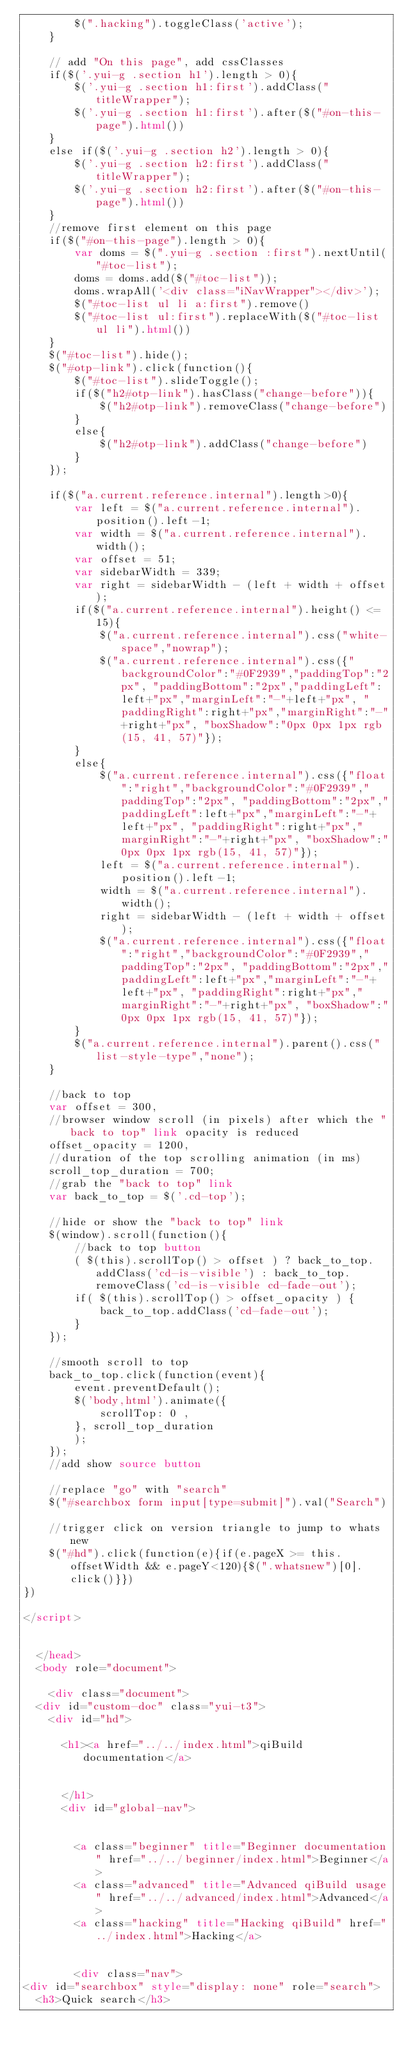Convert code to text. <code><loc_0><loc_0><loc_500><loc_500><_HTML_>        $(".hacking").toggleClass('active');
    }

    // add "On this page", add cssClasses
    if($('.yui-g .section h1').length > 0){
        $('.yui-g .section h1:first').addClass("titleWrapper");
        $('.yui-g .section h1:first').after($("#on-this-page").html())
    }
    else if($('.yui-g .section h2').length > 0){
        $('.yui-g .section h2:first').addClass("titleWrapper");
        $('.yui-g .section h2:first').after($("#on-this-page").html())
    }
    //remove first element on this page
    if($("#on-this-page").length > 0){
        var doms = $(".yui-g .section :first").nextUntil("#toc-list");
        doms = doms.add($("#toc-list"));
        doms.wrapAll('<div class="iNavWrapper"></div>');
        $("#toc-list ul li a:first").remove()
        $("#toc-list ul:first").replaceWith($("#toc-list ul li").html())
    }
    $("#toc-list").hide();
    $("#otp-link").click(function(){
        $("#toc-list").slideToggle();
        if($("h2#otp-link").hasClass("change-before")){
            $("h2#otp-link").removeClass("change-before")
        }
        else{
            $("h2#otp-link").addClass("change-before")
        }
    });

    if($("a.current.reference.internal").length>0){
        var left = $("a.current.reference.internal").position().left-1;
        var width = $("a.current.reference.internal").width();
        var offset = 51;
        var sidebarWidth = 339;
        var right = sidebarWidth - (left + width + offset);
        if($("a.current.reference.internal").height() <= 15){
            $("a.current.reference.internal").css("white-space","nowrap");
            $("a.current.reference.internal").css({"backgroundColor":"#0F2939","paddingTop":"2px", "paddingBottom":"2px","paddingLeft":left+"px","marginLeft":"-"+left+"px", "paddingRight":right+"px","marginRight":"-"+right+"px", "boxShadow":"0px 0px 1px rgb(15, 41, 57)"});
        }
        else{
            $("a.current.reference.internal").css({"float":"right","backgroundColor":"#0F2939","paddingTop":"2px", "paddingBottom":"2px","paddingLeft":left+"px","marginLeft":"-"+left+"px", "paddingRight":right+"px","marginRight":"-"+right+"px", "boxShadow":"0px 0px 1px rgb(15, 41, 57)"});
            left = $("a.current.reference.internal").position().left-1;
            width = $("a.current.reference.internal").width();
            right = sidebarWidth - (left + width + offset);
            $("a.current.reference.internal").css({"float":"right","backgroundColor":"#0F2939","paddingTop":"2px", "paddingBottom":"2px","paddingLeft":left+"px","marginLeft":"-"+left+"px", "paddingRight":right+"px","marginRight":"-"+right+"px", "boxShadow":"0px 0px 1px rgb(15, 41, 57)"});
        }
        $("a.current.reference.internal").parent().css("list-style-type","none");
    }

    //back to top
    var offset = 300,
    //browser window scroll (in pixels) after which the "back to top" link opacity is reduced
    offset_opacity = 1200,
    //duration of the top scrolling animation (in ms)
    scroll_top_duration = 700;
    //grab the "back to top" link
    var back_to_top = $('.cd-top');

    //hide or show the "back to top" link
    $(window).scroll(function(){
        //back to top button
        ( $(this).scrollTop() > offset ) ? back_to_top.addClass('cd-is-visible') : back_to_top.removeClass('cd-is-visible cd-fade-out');
        if( $(this).scrollTop() > offset_opacity ) {
            back_to_top.addClass('cd-fade-out');
        }
    });

    //smooth scroll to top
    back_to_top.click(function(event){
        event.preventDefault();
        $('body,html').animate({
            scrollTop: 0 ,
        }, scroll_top_duration
        );
    });
    //add show source button

    //replace "go" with "search"
    $("#searchbox form input[type=submit]").val("Search")

    //trigger click on version triangle to jump to whats new
    $("#hd").click(function(e){if(e.pageX >= this.offsetWidth && e.pageY<120){$(".whatsnew")[0].click()}})
})

</script>


  </head>
  <body role="document">

    <div class="document">
  <div id="custom-doc" class="yui-t3">
    <div id="hd">
      
      <h1><a href="../../index.html">qiBuild documentation</a>
      
      
      </h1>
      <div id="global-nav">
        
        
        <a class="beginner" title="Beginner documentation" href="../../beginner/index.html">Beginner</a>
        <a class="advanced" title="Advanced qiBuild usage" href="../../advanced/index.html">Advanced</a>
        <a class="hacking" title="Hacking qiBuild" href="../index.html">Hacking</a>
        
        
        <div class="nav">
<div id="searchbox" style="display: none" role="search">
  <h3>Quick search</h3></code> 